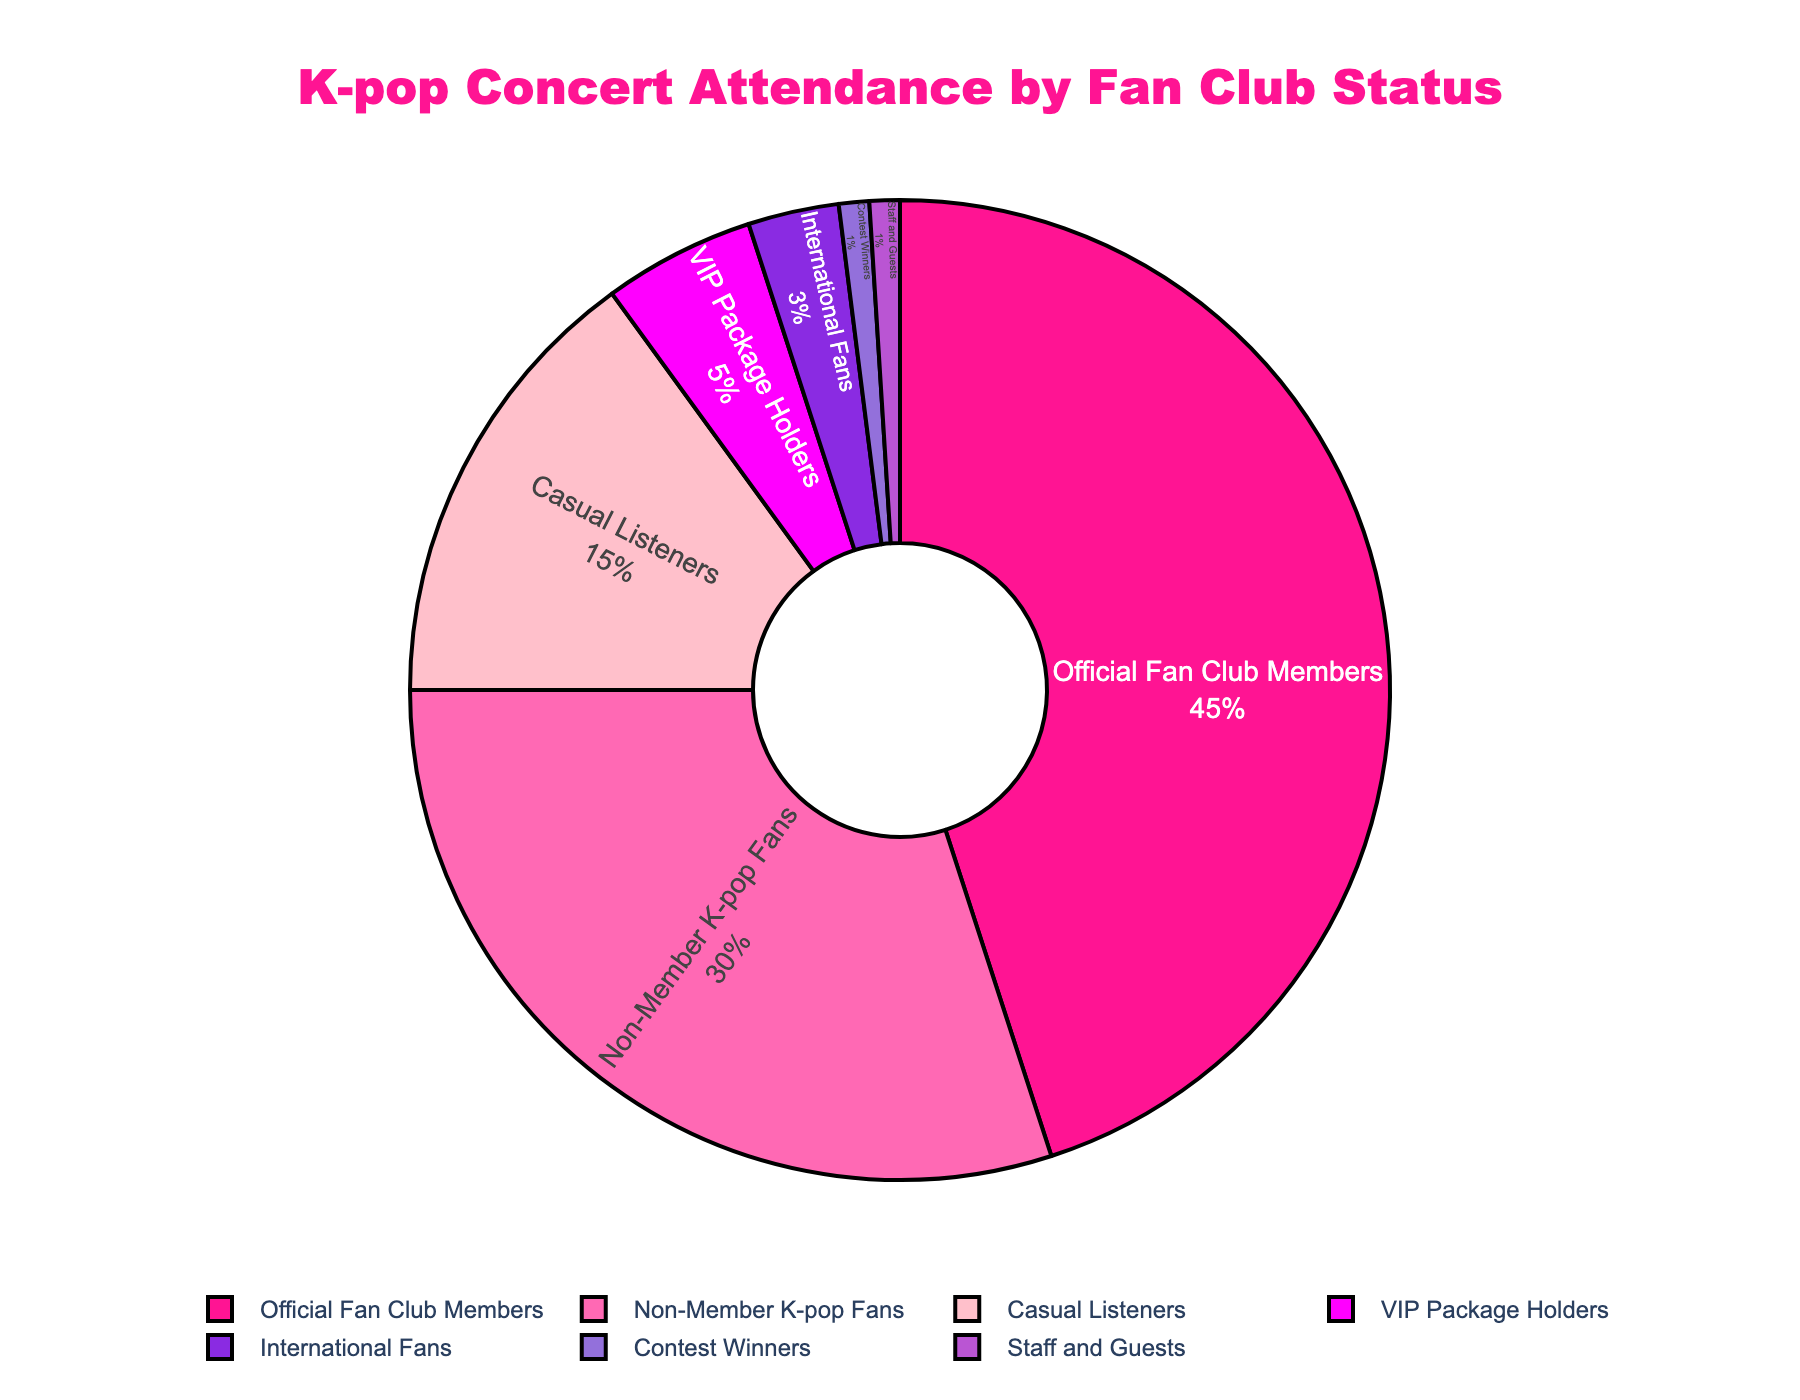What percentage of the attendance is from Official Fan Club Members and VIP Package Holders combined? Add the percentage of Official Fan Club Members (45%) and VIP Package Holders (5%). 45% + 5% = 50%
Answer: 50% Who constitutes a larger portion of the audience: Non-Member K-pop Fans or Casual Listeners? Compare the percentages of Non-Member K-pop Fans (30%) and Casual Listeners (15%). 30% is greater than 15%
Answer: Non-Member K-pop Fans What is the difference in attendance between International Fans and Contest Winners? Subtract the percentage of Contest Winners (1%) from International Fans (3%). 3% - 1% = 2%
Answer: 2% Which group has the smallest representation in the attendance? Identify the group with the smallest percentage in the pie chart, which is Contest Winners (1%) and Staff and Guests (1%)
Answer: Contest Winners and Staff and Guests What is the combined percentage of attendees who are neither Official Fan Club Members nor Non-Member K-pop Fans? Add the percentages of Casual Listeners (15%), VIP Package Holders (5%), International Fans (3%), Contest Winners (1%), and Staff and Guests (1%). 15% + 5% + 3% + 1% + 1% = 25%
Answer: 25% How much bigger is the proportion of Official Fan Club Members compared to International Fans? Subtract the percentage of International Fans (3%) from Official Fan Club Members (45%). 45% - 3% = 42%
Answer: 42% Which attendee group is represented by the color pink in the pie chart? Identify the color pink (#FFC0CB) in the pie chart and match it to the group it represents, which is Casual Listeners
Answer: Casual Listeners How does the percentage of Casual Listeners compare to the percentage of VIP Package Holders? Compare the percentages of Casual Listeners (15%) and VIP Package Holders (5%). 15% is three times greater than 5%
Answer: Casual Listeners What proportion of the audience is made up of people who are not staff or guests? Subtract the percentage of Staff and Guests (1%) from the total (100%). 100% - 1% = 99%
Answer: 99% Which group has a representation of more than 10% but less than 20%? Identify the group within this range, which is Casual Listeners with 15%
Answer: Casual Listeners 